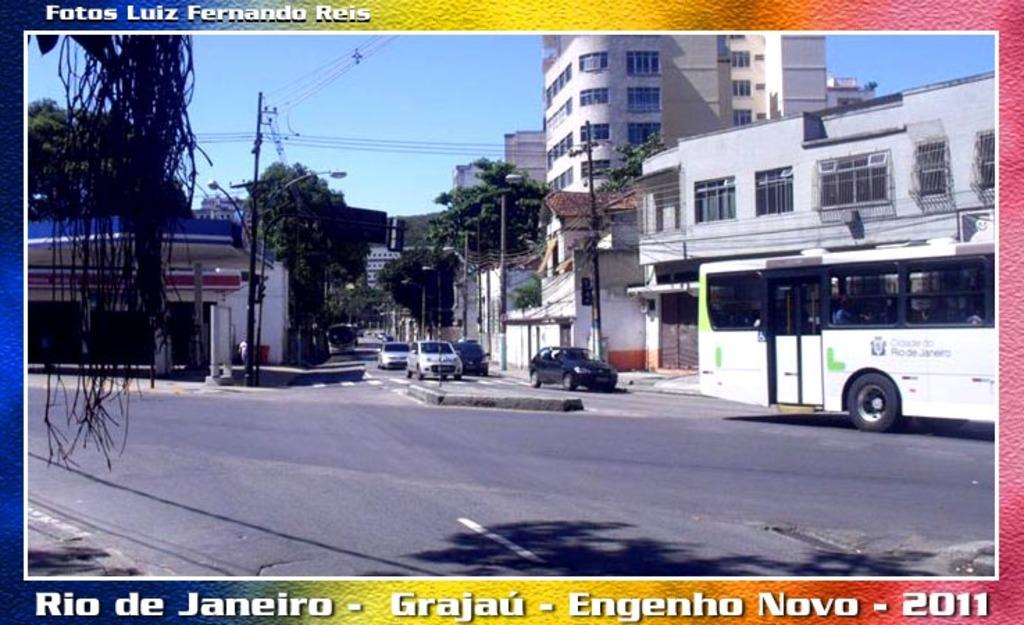<image>
Summarize the visual content of the image. Rio de Janeiro, Grajau, Engenho Novo, 2011 is printed at the bottom of this postcard. 